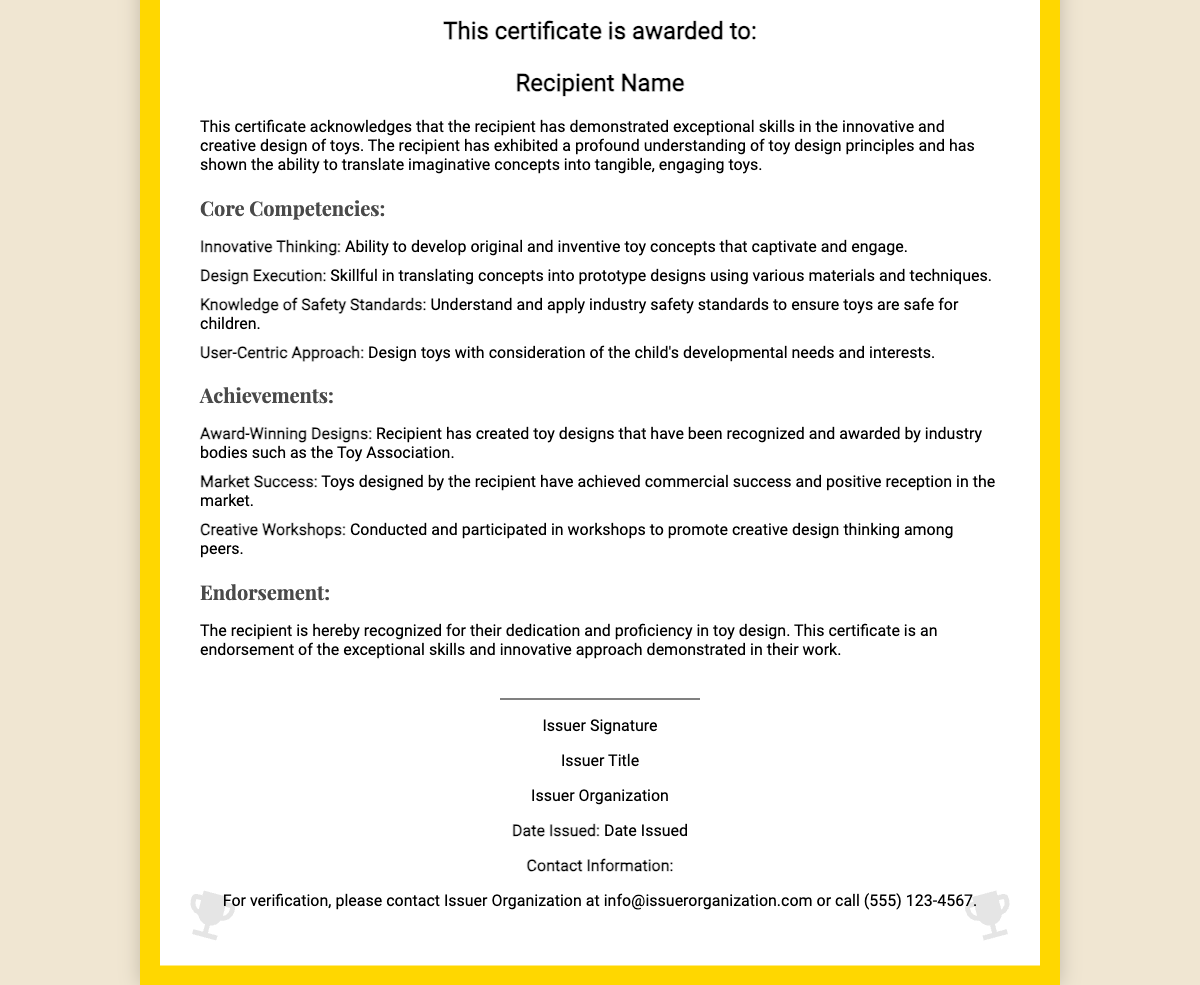What is the title of the certificate? The title is prominently displayed at the top of the document, indicating the certificate's purpose.
Answer: Toy Design Excellence Who is the certificate awarded to? The recipient's name is specified under the 'This certificate is awarded to:' section of the document.
Answer: Recipient Name What is the date issued? The document includes a section labeled 'Date Issued' specifying when the certificate was formally issued.
Answer: Date Issued What is one of the core competencies listed? The competencies are detailed in a section on the document, providing insights into skills recognized by the certificate.
Answer: Innovative Thinking Which organization issued the certificate? The issuer organization is listed at the bottom of the certificate, along with the issuer's title and signature.
Answer: Issuer Organization What type of achievements are noted in the certificate? The achievements section outlines the recipient's notable accomplishments related to toy design.
Answer: Award-Winning Designs How many core competencies are listed in the certificate? The list of competencies is numbered, allowing for straightforward counting of the items presented.
Answer: Four What is the main focus of the endorsement section? The endorsement section summarizes the recognition and skills validation provided by the certificate.
Answer: Dedication and proficiency in toy design What contact information is provided for verification? The document includes a specific email and phone number for the issuer organization in the contact section.
Answer: info@issuerorganization.com or call (555) 123-4567 